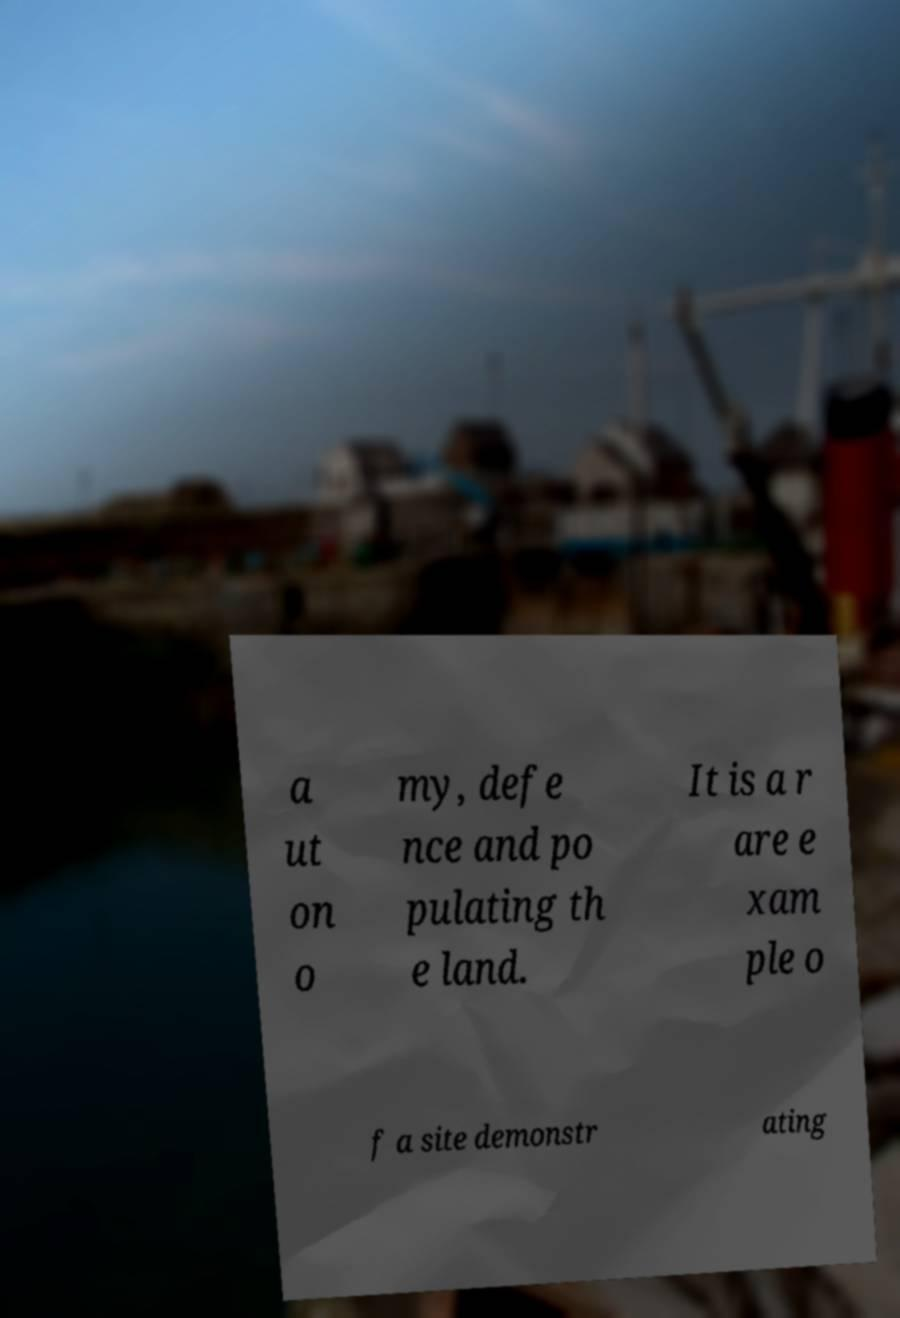Please identify and transcribe the text found in this image. a ut on o my, defe nce and po pulating th e land. It is a r are e xam ple o f a site demonstr ating 